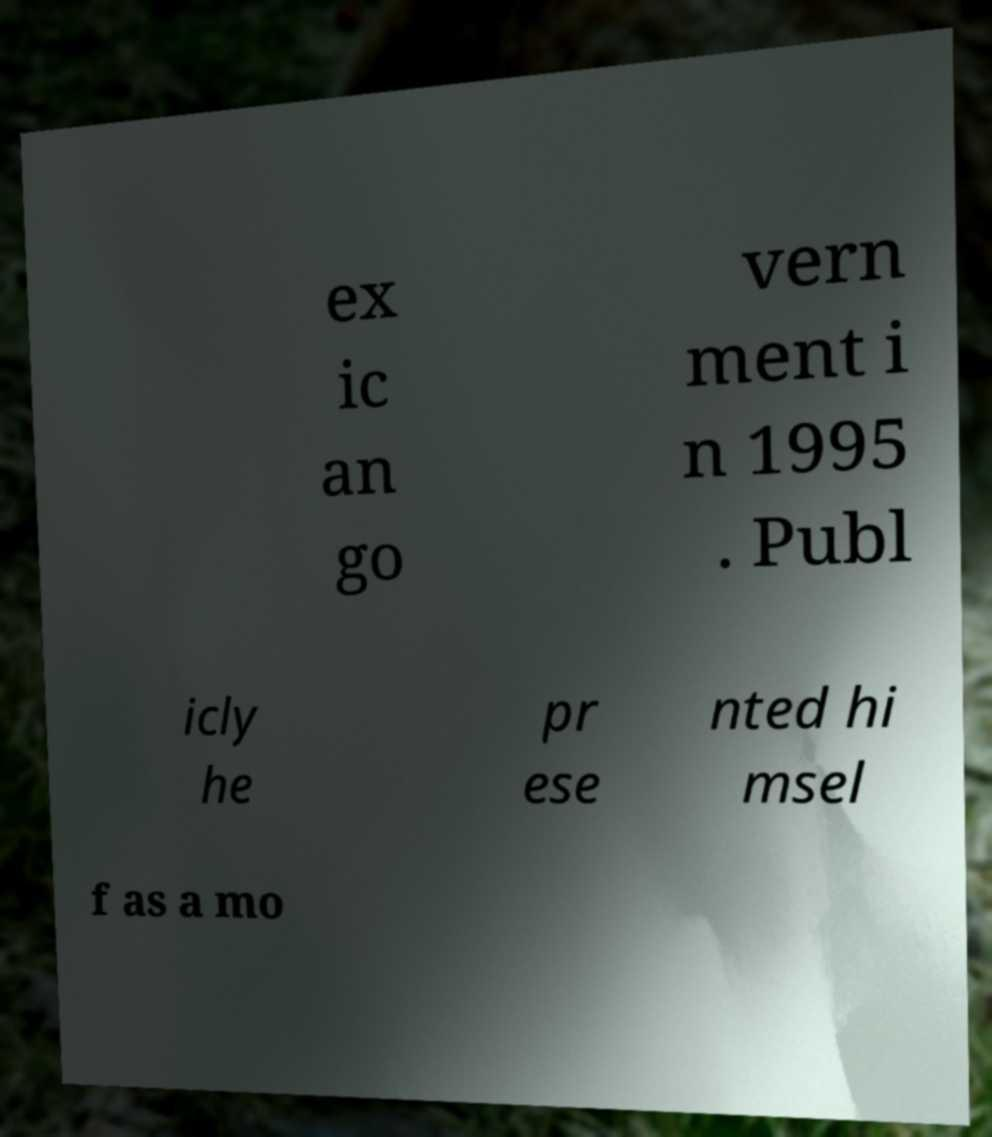Please read and relay the text visible in this image. What does it say? ex ic an go vern ment i n 1995 . Publ icly he pr ese nted hi msel f as a mo 